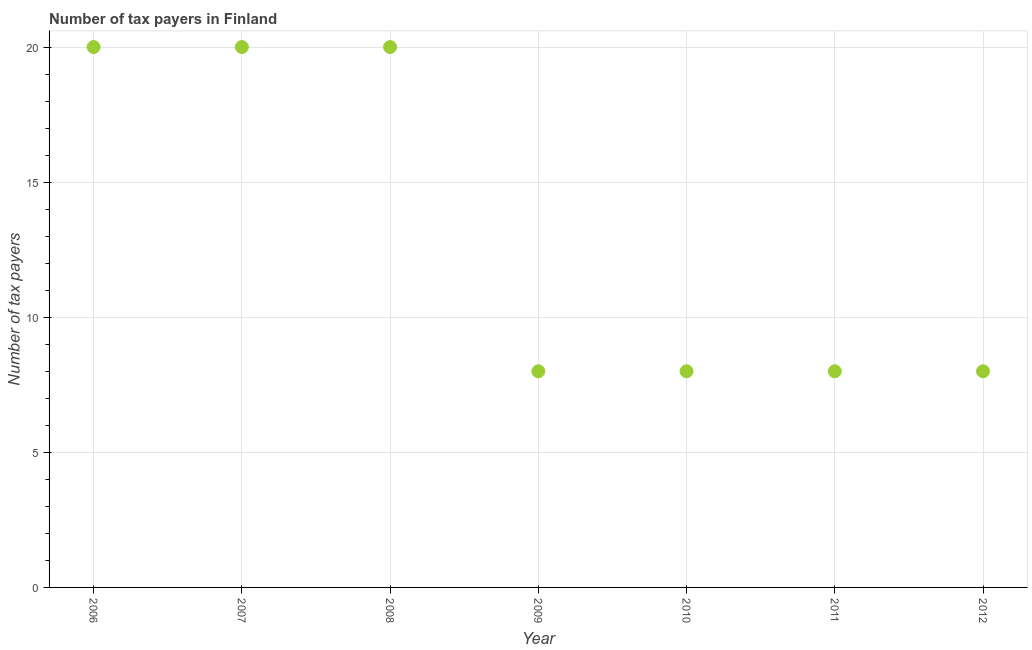What is the number of tax payers in 2006?
Give a very brief answer. 20. Across all years, what is the maximum number of tax payers?
Keep it short and to the point. 20. Across all years, what is the minimum number of tax payers?
Ensure brevity in your answer.  8. In which year was the number of tax payers maximum?
Make the answer very short. 2006. In which year was the number of tax payers minimum?
Provide a short and direct response. 2009. What is the sum of the number of tax payers?
Offer a terse response. 92. What is the difference between the number of tax payers in 2006 and 2010?
Your answer should be compact. 12. What is the average number of tax payers per year?
Make the answer very short. 13.14. What is the median number of tax payers?
Provide a short and direct response. 8. Is the number of tax payers in 2008 less than that in 2010?
Provide a short and direct response. No. Is the difference between the number of tax payers in 2006 and 2008 greater than the difference between any two years?
Give a very brief answer. No. What is the difference between the highest and the second highest number of tax payers?
Provide a succinct answer. 0. What is the difference between the highest and the lowest number of tax payers?
Your response must be concise. 12. How many years are there in the graph?
Ensure brevity in your answer.  7. What is the difference between two consecutive major ticks on the Y-axis?
Provide a short and direct response. 5. Does the graph contain grids?
Make the answer very short. Yes. What is the title of the graph?
Keep it short and to the point. Number of tax payers in Finland. What is the label or title of the Y-axis?
Keep it short and to the point. Number of tax payers. What is the Number of tax payers in 2007?
Ensure brevity in your answer.  20. What is the Number of tax payers in 2008?
Your answer should be very brief. 20. What is the Number of tax payers in 2009?
Offer a very short reply. 8. What is the Number of tax payers in 2010?
Make the answer very short. 8. What is the Number of tax payers in 2011?
Give a very brief answer. 8. What is the Number of tax payers in 2012?
Give a very brief answer. 8. What is the difference between the Number of tax payers in 2006 and 2008?
Your answer should be very brief. 0. What is the difference between the Number of tax payers in 2006 and 2010?
Offer a terse response. 12. What is the difference between the Number of tax payers in 2006 and 2011?
Provide a succinct answer. 12. What is the difference between the Number of tax payers in 2007 and 2011?
Provide a succinct answer. 12. What is the difference between the Number of tax payers in 2007 and 2012?
Your answer should be compact. 12. What is the difference between the Number of tax payers in 2008 and 2010?
Provide a short and direct response. 12. What is the difference between the Number of tax payers in 2009 and 2010?
Your answer should be very brief. 0. What is the difference between the Number of tax payers in 2009 and 2012?
Provide a succinct answer. 0. What is the difference between the Number of tax payers in 2010 and 2012?
Make the answer very short. 0. What is the ratio of the Number of tax payers in 2006 to that in 2008?
Provide a short and direct response. 1. What is the ratio of the Number of tax payers in 2006 to that in 2011?
Offer a very short reply. 2.5. What is the ratio of the Number of tax payers in 2006 to that in 2012?
Your answer should be very brief. 2.5. What is the ratio of the Number of tax payers in 2007 to that in 2008?
Provide a succinct answer. 1. What is the ratio of the Number of tax payers in 2007 to that in 2011?
Ensure brevity in your answer.  2.5. What is the ratio of the Number of tax payers in 2007 to that in 2012?
Provide a succinct answer. 2.5. What is the ratio of the Number of tax payers in 2008 to that in 2009?
Give a very brief answer. 2.5. What is the ratio of the Number of tax payers in 2008 to that in 2010?
Offer a very short reply. 2.5. What is the ratio of the Number of tax payers in 2009 to that in 2011?
Provide a succinct answer. 1. What is the ratio of the Number of tax payers in 2009 to that in 2012?
Offer a terse response. 1. What is the ratio of the Number of tax payers in 2010 to that in 2011?
Make the answer very short. 1. What is the ratio of the Number of tax payers in 2010 to that in 2012?
Your answer should be compact. 1. 